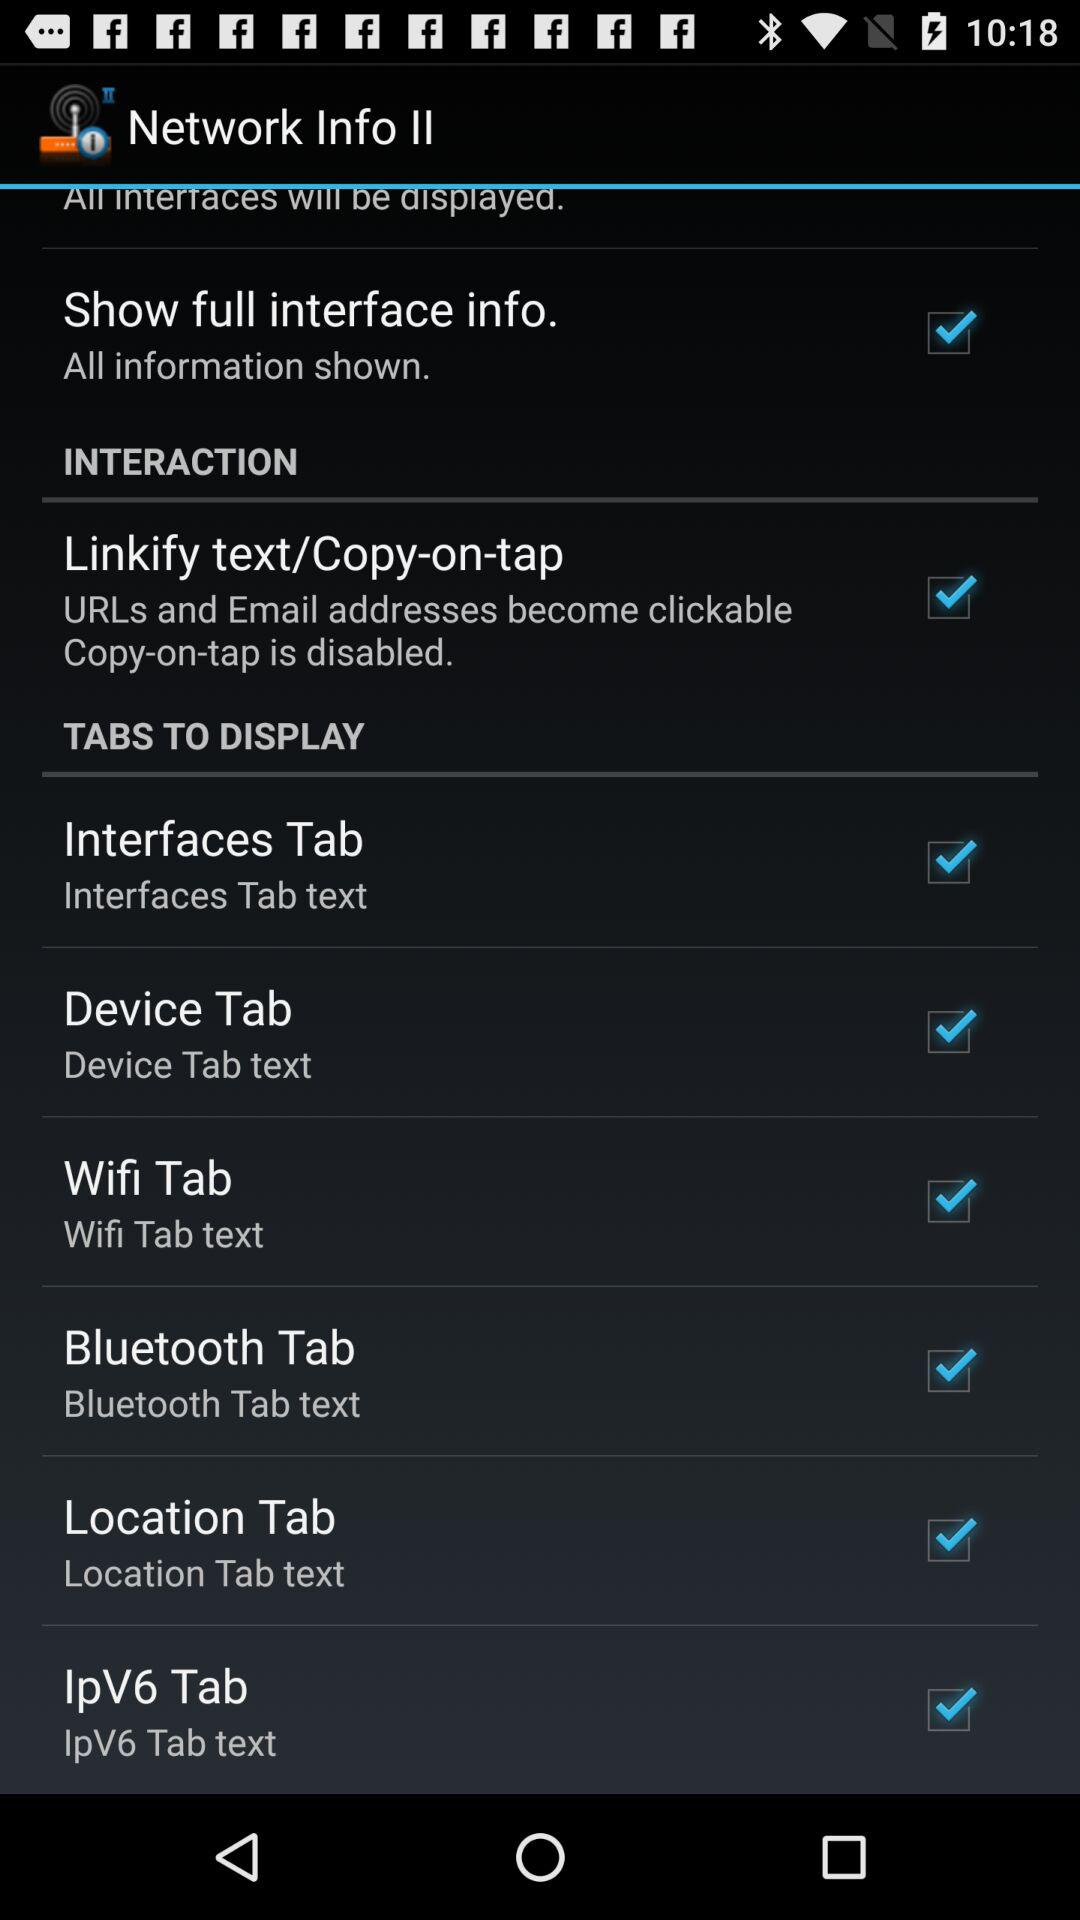What is the status of "Bluetooth Tab"? The status of "Bluetooth Tab" is "on". 